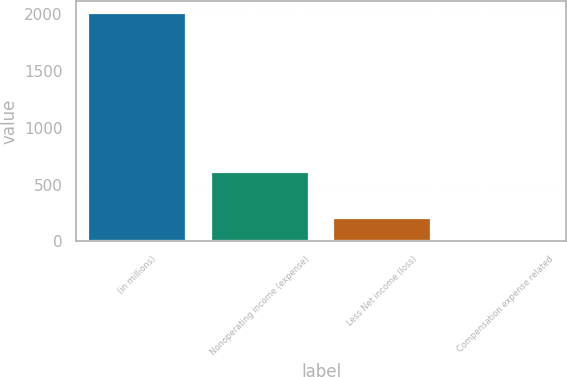<chart> <loc_0><loc_0><loc_500><loc_500><bar_chart><fcel>(in millions)<fcel>Nonoperating income (expense)<fcel>Less Net income (loss)<fcel>Compensation expense related<nl><fcel>2014<fcel>609.1<fcel>207.7<fcel>7<nl></chart> 